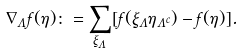Convert formula to latex. <formula><loc_0><loc_0><loc_500><loc_500>\nabla _ { \Lambda } f ( \eta ) \colon = \sum _ { \xi _ { \Lambda } } [ f ( \xi _ { \Lambda } \eta _ { \Lambda ^ { c } } ) - f ( \eta ) ] .</formula> 